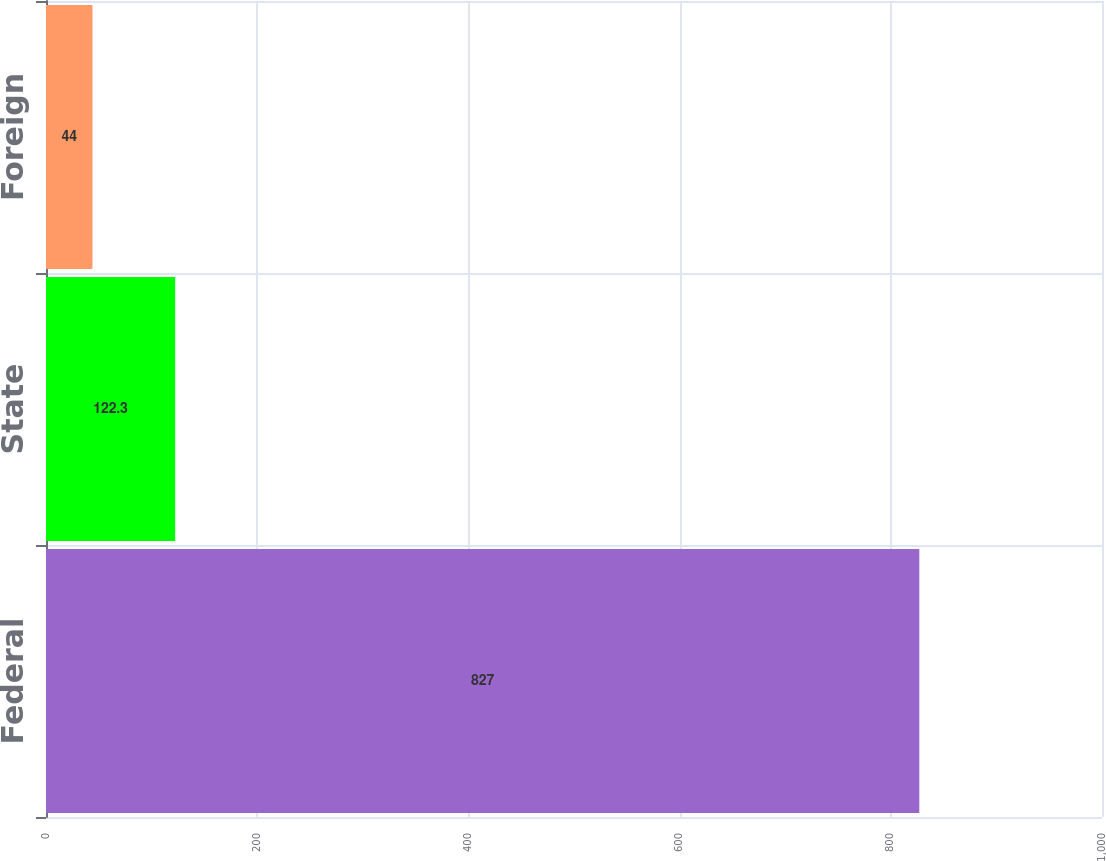<chart> <loc_0><loc_0><loc_500><loc_500><bar_chart><fcel>Federal<fcel>State<fcel>Foreign<nl><fcel>827<fcel>122.3<fcel>44<nl></chart> 